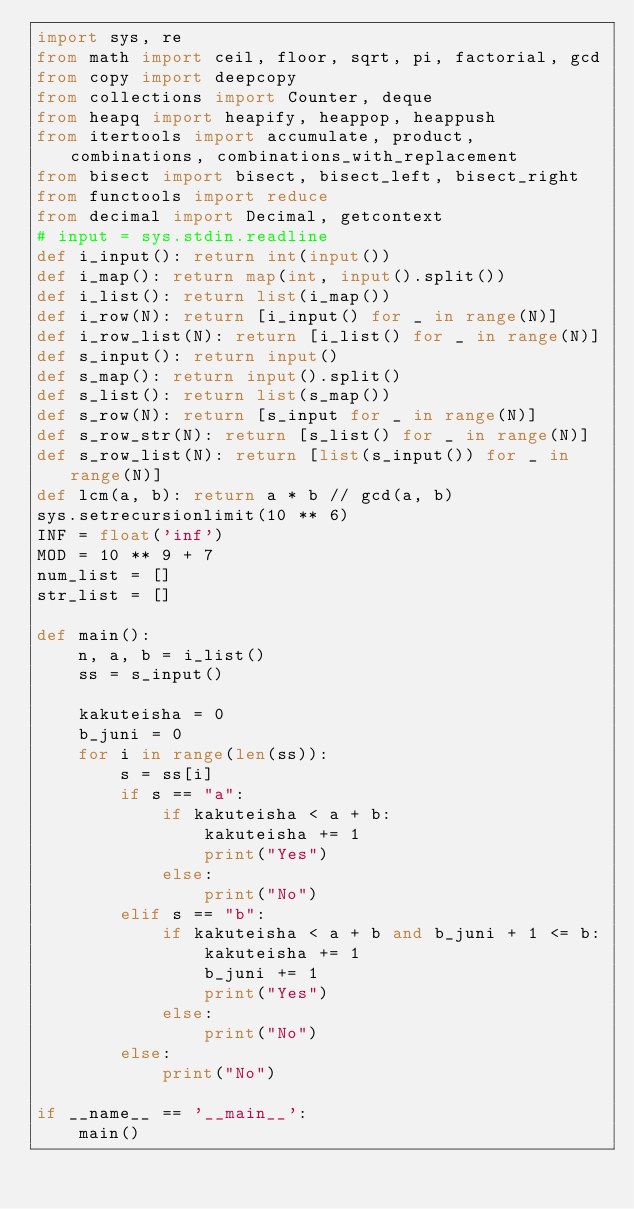<code> <loc_0><loc_0><loc_500><loc_500><_Python_>import sys, re
from math import ceil, floor, sqrt, pi, factorial, gcd
from copy import deepcopy
from collections import Counter, deque
from heapq import heapify, heappop, heappush
from itertools import accumulate, product, combinations, combinations_with_replacement
from bisect import bisect, bisect_left, bisect_right
from functools import reduce
from decimal import Decimal, getcontext
# input = sys.stdin.readline 
def i_input(): return int(input())
def i_map(): return map(int, input().split())
def i_list(): return list(i_map())
def i_row(N): return [i_input() for _ in range(N)]
def i_row_list(N): return [i_list() for _ in range(N)]
def s_input(): return input()
def s_map(): return input().split()
def s_list(): return list(s_map())
def s_row(N): return [s_input for _ in range(N)]
def s_row_str(N): return [s_list() for _ in range(N)]
def s_row_list(N): return [list(s_input()) for _ in range(N)]
def lcm(a, b): return a * b // gcd(a, b)
sys.setrecursionlimit(10 ** 6)
INF = float('inf')
MOD = 10 ** 9 + 7
num_list = []
str_list = []

def main():
    n, a, b = i_list()
    ss = s_input()

    kakuteisha = 0
    b_juni = 0
    for i in range(len(ss)):
        s = ss[i]
        if s == "a":
            if kakuteisha < a + b:
                kakuteisha += 1
                print("Yes")
            else:
                print("No")
        elif s == "b":
            if kakuteisha < a + b and b_juni + 1 <= b:
                kakuteisha += 1
                b_juni += 1
                print("Yes")
            else:
                print("No")
        else:
            print("No")

if __name__ == '__main__':
    main()
</code> 